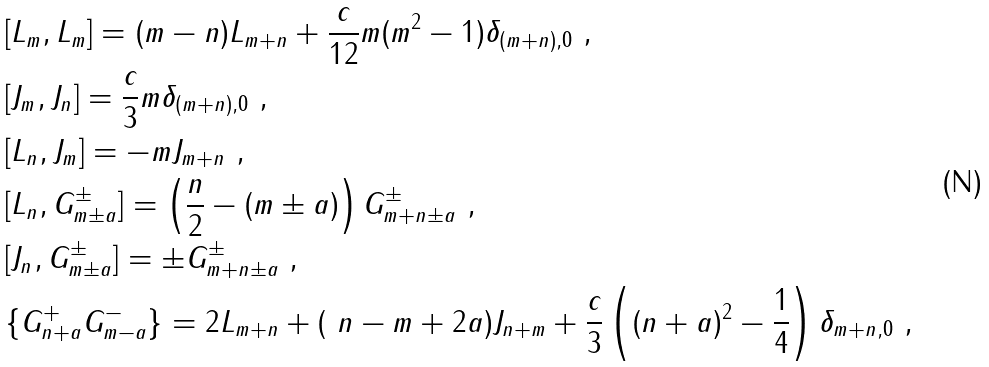Convert formula to latex. <formula><loc_0><loc_0><loc_500><loc_500>& [ L _ { m } , L _ { m } ] = ( m - n ) L _ { m + n } + \frac { c } { 1 2 } m ( m ^ { 2 } - 1 ) \delta _ { ( m + n ) , 0 } \ , \\ & [ J _ { m } , J _ { n } ] = \frac { c } { 3 } m \delta _ { ( m + n ) , 0 } \ , \\ & [ L _ { n } , J _ { m } ] = - m J _ { m + n } \ , \\ & [ L _ { n } , G ^ { \pm } _ { m \pm a } ] = \left ( \frac { n } { 2 } - ( m \pm a ) \right ) G ^ { \pm } _ { m + n \pm a } \ , \\ & [ J _ { n } , G ^ { \pm } _ { m \pm a } ] = \pm G ^ { \pm } _ { m + n \pm a } \ , \\ & \{ G ^ { + } _ { n + a } G ^ { - } _ { m - a } \} = 2 L _ { m + n } + ( \ n - m + 2 a ) J _ { n + m } + \frac { c } { 3 } \left ( ( n + a ) ^ { 2 } - \frac { 1 } { 4 } \right ) \delta _ { m + n , 0 } \ ,</formula> 